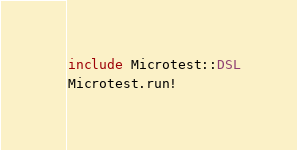<code> <loc_0><loc_0><loc_500><loc_500><_Crystal_>include Microtest::DSL
Microtest.run!
</code> 